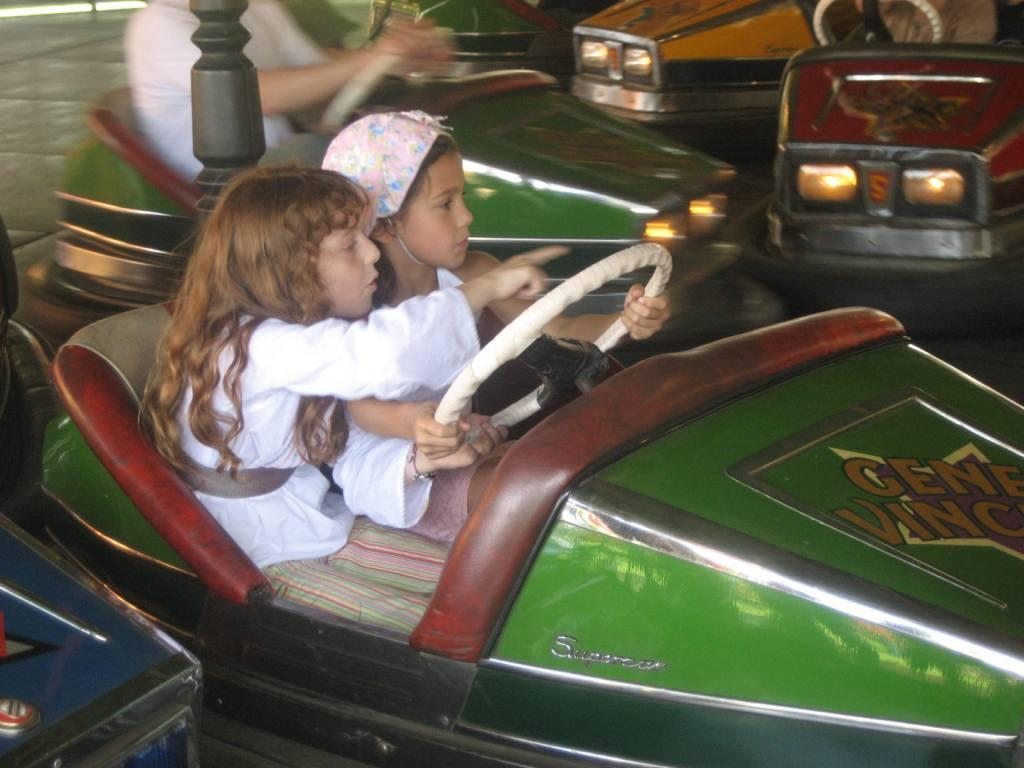What is the child in the image doing? The child is sitting in a car and driving it. Who is sitting beside the driver in the car? There is another child sitting beside the driver in the car. What can be seen in the background of the image? There is another car in the image. What is the person in the other car doing? The person in the other car is holding a steering wheel. What type of light is hanging from the ceiling in the image? There is no mention of a light hanging from the ceiling in the image; it is focused on the cars and the people inside them. 